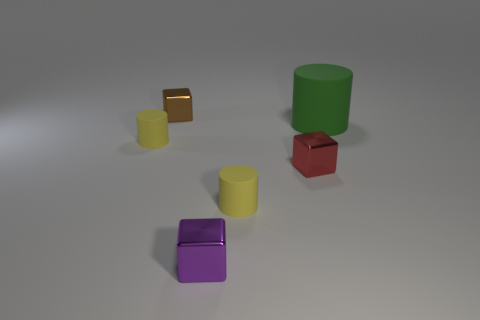There is a tiny thing that is left of the tiny brown block; what is its color?
Your answer should be very brief. Yellow. There is a small yellow matte thing that is on the left side of the purple thing; is its shape the same as the big object behind the purple cube?
Ensure brevity in your answer.  Yes. Are there any other shiny things of the same size as the brown object?
Your answer should be compact. Yes. What is the small purple object that is on the right side of the small brown thing made of?
Provide a succinct answer. Metal. Is the material of the tiny yellow cylinder right of the small purple shiny cube the same as the big green thing?
Make the answer very short. Yes. Is there a tiny blue matte sphere?
Offer a terse response. No. The thing that is in front of the yellow matte cylinder that is right of the tiny thing that is behind the large thing is what color?
Give a very brief answer. Purple. Does the brown shiny thing have the same size as the yellow thing on the right side of the purple cube?
Keep it short and to the point. Yes. What number of objects are either cylinders that are in front of the green matte object or yellow things that are on the left side of the large cylinder?
Ensure brevity in your answer.  2. The purple metal thing that is the same size as the red shiny block is what shape?
Offer a very short reply. Cube. 